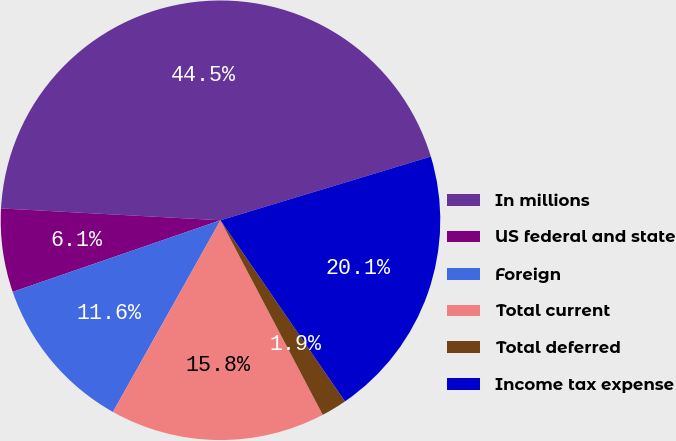Convert chart to OTSL. <chart><loc_0><loc_0><loc_500><loc_500><pie_chart><fcel>In millions<fcel>US federal and state<fcel>Foreign<fcel>Total current<fcel>Total deferred<fcel>Income tax expense<nl><fcel>44.46%<fcel>6.14%<fcel>11.58%<fcel>15.84%<fcel>1.88%<fcel>20.1%<nl></chart> 